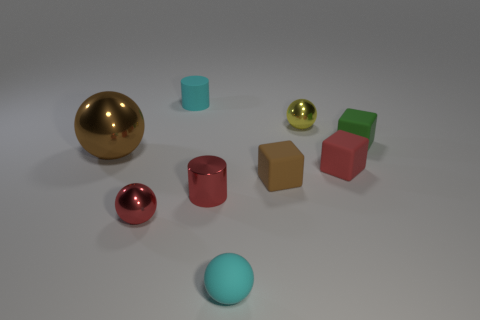Subtract all cyan matte spheres. How many spheres are left? 3 Add 1 small cubes. How many objects exist? 10 Subtract 1 cylinders. How many cylinders are left? 1 Subtract all purple cubes. Subtract all cyan cylinders. How many cubes are left? 3 Subtract all purple cubes. How many blue cylinders are left? 0 Subtract all big red rubber cubes. Subtract all yellow things. How many objects are left? 8 Add 4 red shiny cylinders. How many red shiny cylinders are left? 5 Add 9 large brown metal spheres. How many large brown metal spheres exist? 10 Subtract all brown blocks. How many blocks are left? 2 Subtract 1 red balls. How many objects are left? 8 